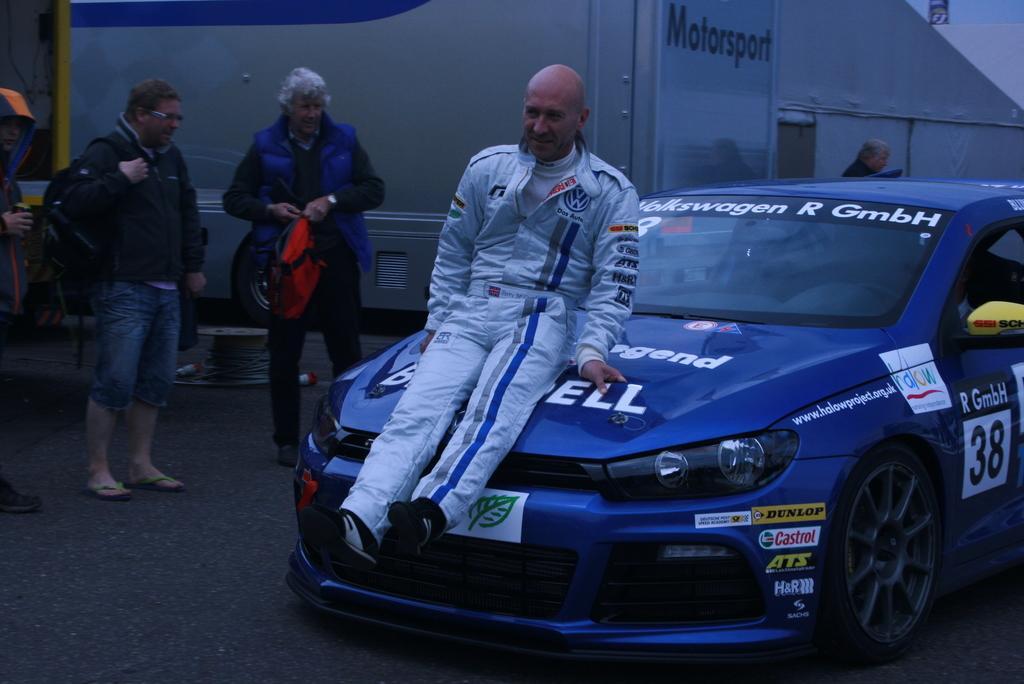Can you describe this image briefly? In this image in the middle a man wearing white dress is sitting on a car. In the left there are three person. In the background there is building. 